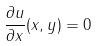Convert formula to latex. <formula><loc_0><loc_0><loc_500><loc_500>\frac { \partial u } { \partial x } ( x , y ) = 0</formula> 